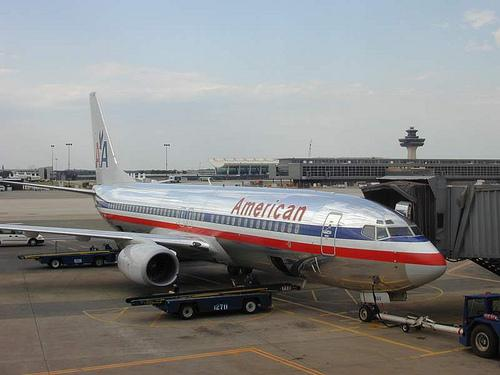Provide a concise description of the primary object in the image. An American Airlines plane is parked at the airport terminal, with a sky backdrop and various airport-related elements. Present a condensed description of the core object in the image and its context. An American Airlines airplane is the focal point of the image, stationed at an airport with a vibrant sky and other airport elements. In a few words, state what the main focus of the image is. American Airlines plane at airport. Briefly explain the most crucial detail in the image and its surroundings. An American Airlines plane is the centerpiece of the image, with a backdrop of an airport setting and a blue sky. Write a summarized depiction of the image and its principal focus. The image captures an American Airlines airplane stationed at an airport with a blue sky background and other airport elements. Give an overview of the main scene in the image and its noteworthy features. A large American Airlines airplane is stationed at an airport, with distinct features like the sky, terminal, and control tower. Create a short narrative about the image's main subject and its environment. The image presents an American Airlines plane that is standing by at an airport, with a picturesque blue sky and various airport features. Narrate the image setting and the major object involved. At an airport, an American Airlines airplane stands parked near the terminal, with a blue sky background. Describe the central object in the image and any significant aspects around it. The image features an American Airlines plane at an airport, alongside the sky, terminal building, and control tower. Form a brief account of the primary components and surroundings in the photo. The image shows an American Airlines plane parked at an airport, with the sky, terminal, control tower, and runway visible. The jet engine is on the left side of the plane, isn't it? The jet engine is actually on the right side of the plane, not the left. The control tower is on the far left side of the image, right? The control tower is actually on the right side of the image, not the left. Do you notice the elephant-shaped balloon floating above the airport? There is no elephant-shaped balloon in the image. This instruction introduces an object that doesn't exist in the image. Aren't all the plane's wheels hidden from view in this picture? The image shows the front wheels of the plane, so they are not all hidden from view. Is the sky in this image filled with dark, stormy clouds? The image actually shows a blue sky with white clouds, not dark and stormy ones. The airplane has the word "European" written on its side, correct? The airplane has the word "American" written on its side, not "European." Find the green container used for passengers to board the plane. The image features a tunnel for passengers to board the plane, but the color is not specified. Mentioning a green container is misleading. Can you find the airport terminal on the left side of the image? The airport terminal is actually in the background in the center part of the image, not on the left side. Can you spot the red car parked beside the airplane? The image has a white car, not a red one, and it is to the left of the airplane. The airplane appears to be flying high in the sky, doesn't it? The airplane is parked on the ground at the airport terminal, not flying high in the sky. 